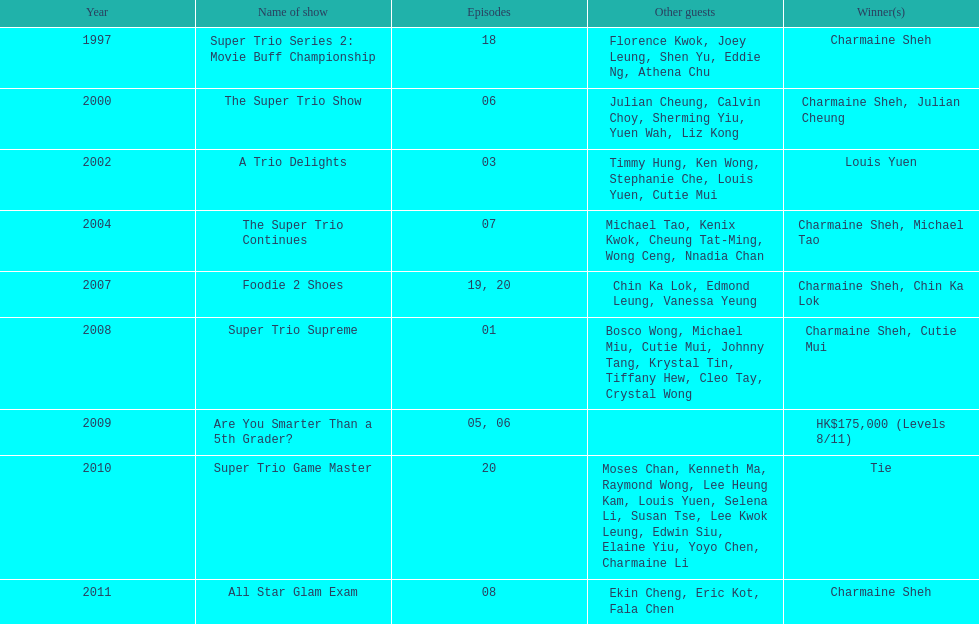What is the count of tv shows charmaine sheh has participated in? 9. 